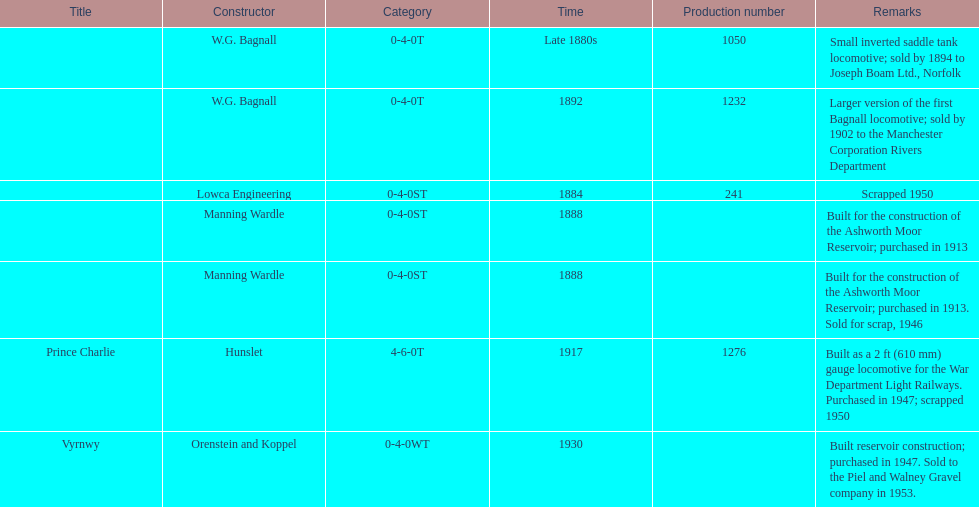How many locomotives were built after 1900? 2. Can you give me this table as a dict? {'header': ['Title', 'Constructor', 'Category', 'Time', 'Production number', 'Remarks'], 'rows': [['', 'W.G. Bagnall', '0-4-0T', 'Late 1880s', '1050', 'Small inverted saddle tank locomotive; sold by 1894 to Joseph Boam Ltd., Norfolk'], ['', 'W.G. Bagnall', '0-4-0T', '1892', '1232', 'Larger version of the first Bagnall locomotive; sold by 1902 to the Manchester Corporation Rivers Department'], ['', 'Lowca Engineering', '0-4-0ST', '1884', '241', 'Scrapped 1950'], ['', 'Manning Wardle', '0-4-0ST', '1888', '', 'Built for the construction of the Ashworth Moor Reservoir; purchased in 1913'], ['', 'Manning Wardle', '0-4-0ST', '1888', '', 'Built for the construction of the Ashworth Moor Reservoir; purchased in 1913. Sold for scrap, 1946'], ['Prince Charlie', 'Hunslet', '4-6-0T', '1917', '1276', 'Built as a 2\xa0ft (610\xa0mm) gauge locomotive for the War Department Light Railways. Purchased in 1947; scrapped 1950'], ['Vyrnwy', 'Orenstein and Koppel', '0-4-0WT', '1930', '', 'Built reservoir construction; purchased in 1947. Sold to the Piel and Walney Gravel company in 1953.']]} 